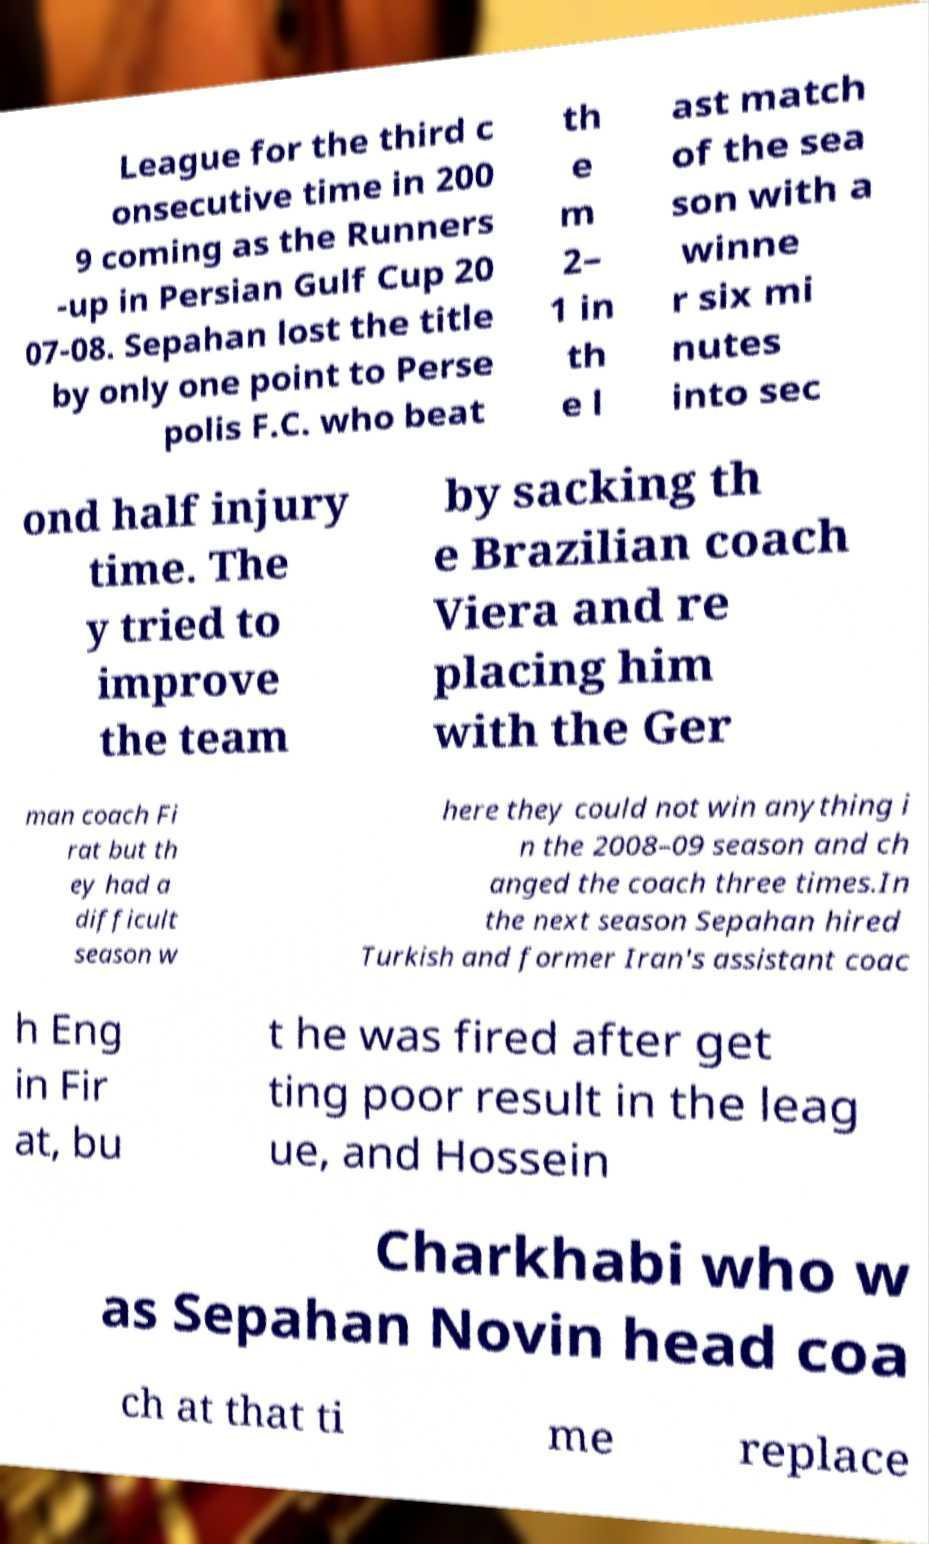Could you assist in decoding the text presented in this image and type it out clearly? League for the third c onsecutive time in 200 9 coming as the Runners -up in Persian Gulf Cup 20 07-08. Sepahan lost the title by only one point to Perse polis F.C. who beat th e m 2– 1 in th e l ast match of the sea son with a winne r six mi nutes into sec ond half injury time. The y tried to improve the team by sacking th e Brazilian coach Viera and re placing him with the Ger man coach Fi rat but th ey had a difficult season w here they could not win anything i n the 2008–09 season and ch anged the coach three times.In the next season Sepahan hired Turkish and former Iran's assistant coac h Eng in Fir at, bu t he was fired after get ting poor result in the leag ue, and Hossein Charkhabi who w as Sepahan Novin head coa ch at that ti me replace 